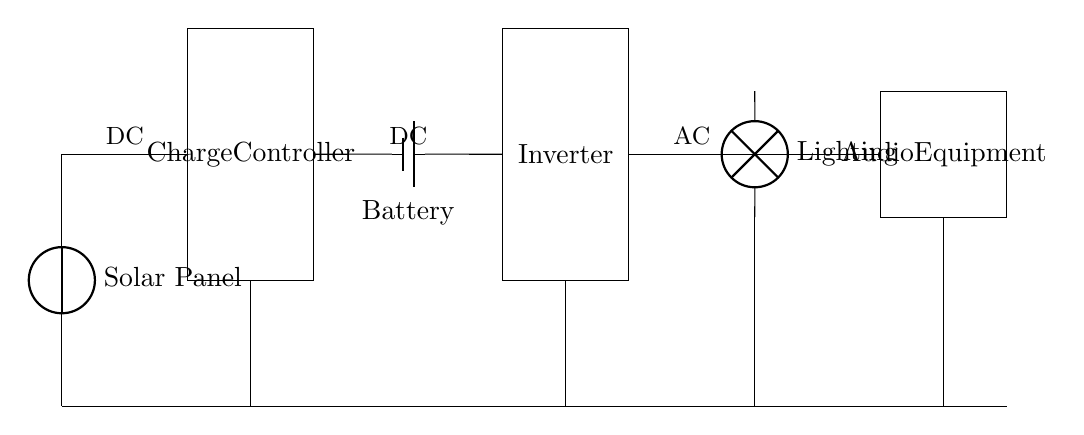What component converts solar energy to electrical energy? The solar panel is the component that converts solar energy into electrical energy by utilizing photovoltaic cells, which generate electricity when exposed to sunlight.
Answer: Solar Panel What is the purpose of the charge controller? The charge controller regulates the voltage and current coming from the solar panel to prevent overcharging the battery, ensuring safe and efficient charging.
Answer: Regulates charging What type of current does the inverter convert? The inverter converts direct current (DC) from the battery and charge controller into alternating current (AC) suitable for powering standard electrical equipment.
Answer: Direct current How many main components are there in the circuit? The circuit contains five main components: Solar Panel, Charge Controller, Battery, Inverter, and the outputs for Lighting and Audio Equipment.
Answer: Five Which two equipment types receive output from the inverter? The inverter provides output to two types of equipment: Lighting and Audio Equipment, allowing the church to use electricity generated from the solar energy.
Answer: Lighting and Audio Equipment What is the function of the battery in this circuit? The battery stores the electrical energy generated by the solar panel for later use, ensuring a continuous power supply for the lighting and audio equipment, even when solar energy isn’t available.
Answer: Energy storage 